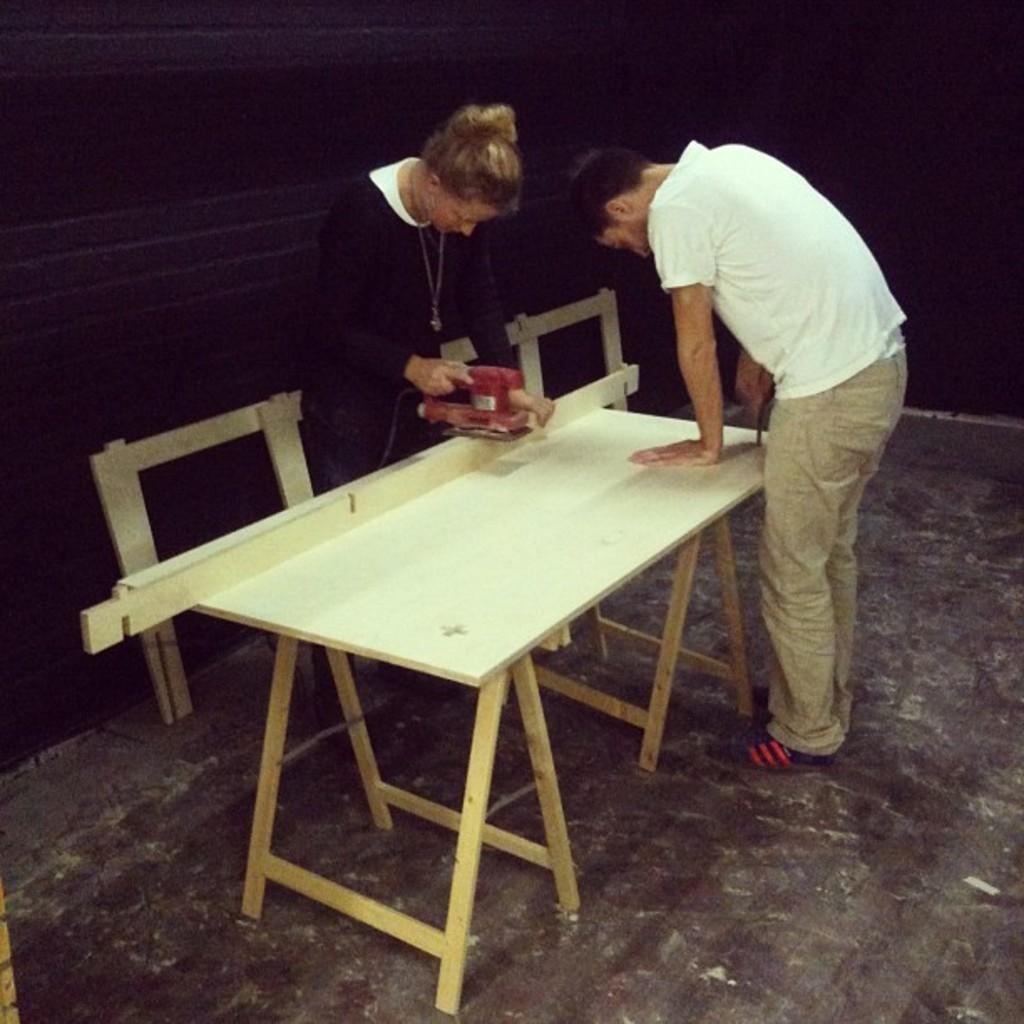What is the lady in the image wearing? The lady is wearing a black dress. What is the lady doing in the image? The lady is cutting wood with a cutting machine. What is the man in the image wearing? The man is wearing a white t-shirt. Where is the man positioned in relation to the lady? The man is standing in front of the lady. What piece of furniture is present in the image? There is a table in the image. What type of weather can be seen in the image? There is no indication of the weather in the image, as it is focused on the lady and the man. Is there a parcel being delivered in the image? There is no parcel present in the image. 